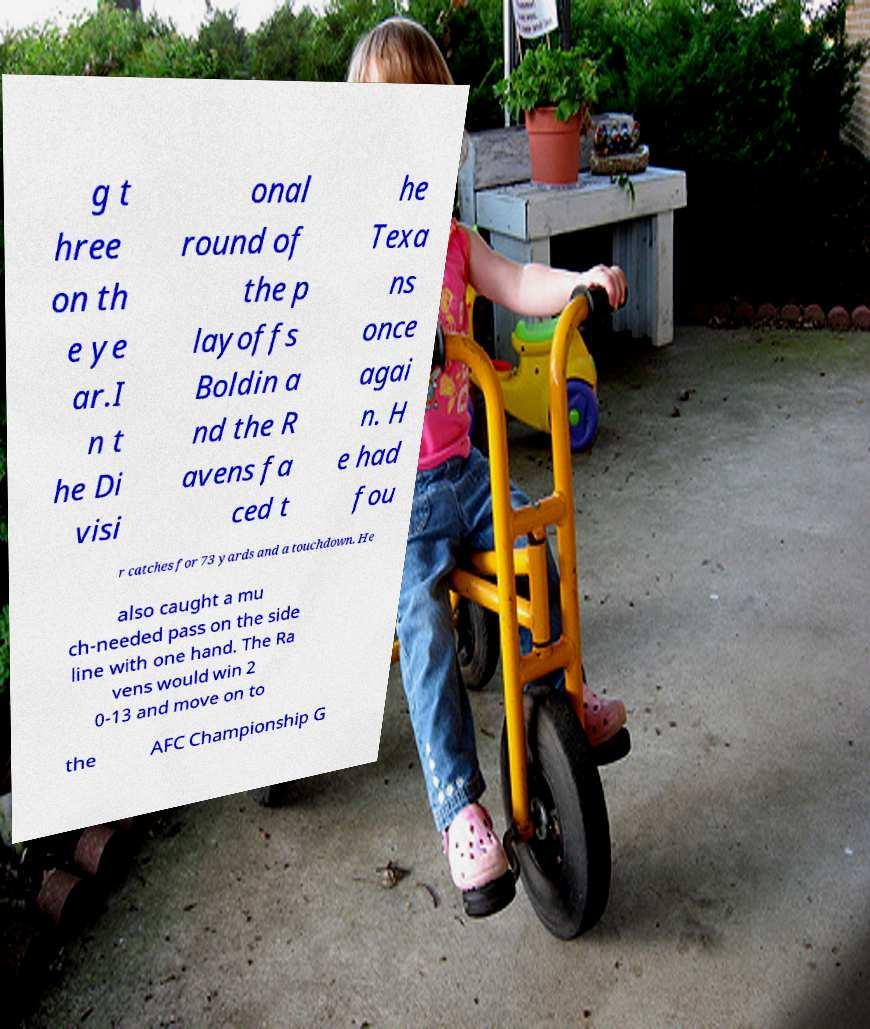Could you assist in decoding the text presented in this image and type it out clearly? g t hree on th e ye ar.I n t he Di visi onal round of the p layoffs Boldin a nd the R avens fa ced t he Texa ns once agai n. H e had fou r catches for 73 yards and a touchdown. He also caught a mu ch-needed pass on the side line with one hand. The Ra vens would win 2 0-13 and move on to the AFC Championship G 